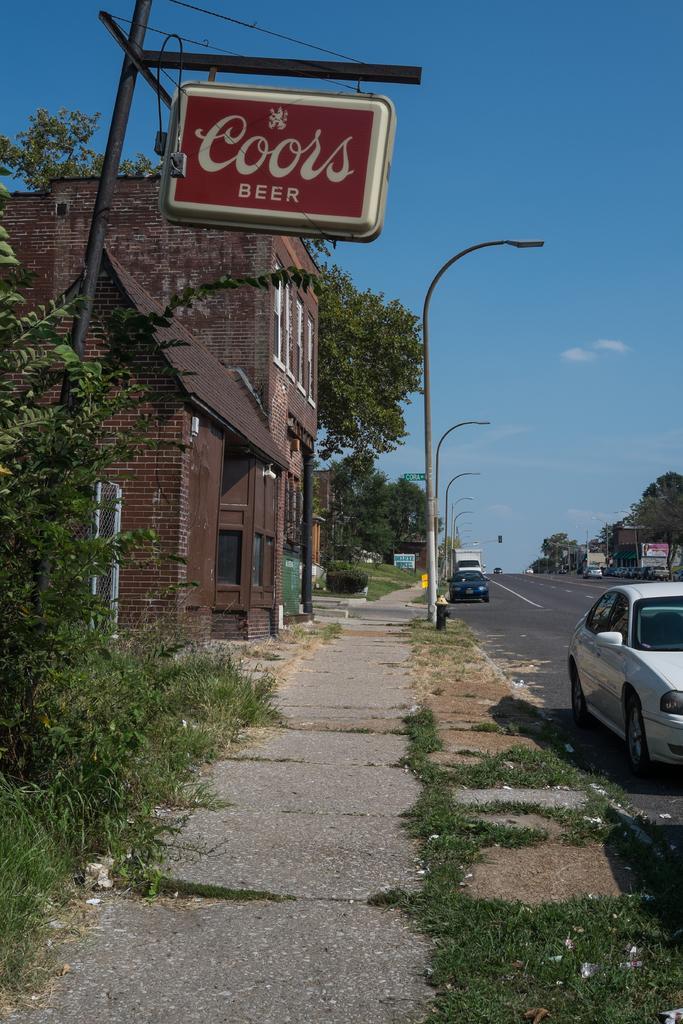Describe this image in one or two sentences. As we can see in the image there are trees, street lamps, buildings, sky and cars. 